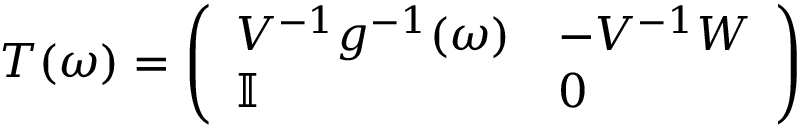<formula> <loc_0><loc_0><loc_500><loc_500>\begin{array} { r } { T ( \omega ) = \left ( \begin{array} { l l } { V ^ { - 1 } g ^ { - 1 } ( \omega ) } & { - V ^ { - 1 } W } \\ { \mathbb { I } } & { 0 } \end{array} \right ) } \end{array}</formula> 